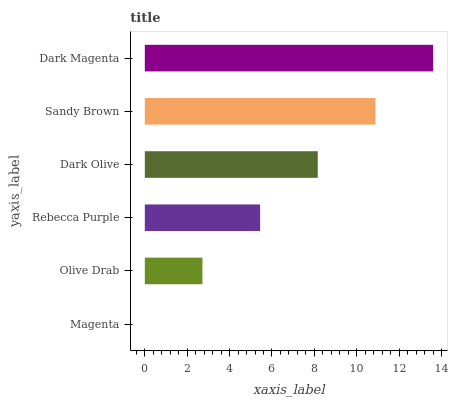Is Magenta the minimum?
Answer yes or no. Yes. Is Dark Magenta the maximum?
Answer yes or no. Yes. Is Olive Drab the minimum?
Answer yes or no. No. Is Olive Drab the maximum?
Answer yes or no. No. Is Olive Drab greater than Magenta?
Answer yes or no. Yes. Is Magenta less than Olive Drab?
Answer yes or no. Yes. Is Magenta greater than Olive Drab?
Answer yes or no. No. Is Olive Drab less than Magenta?
Answer yes or no. No. Is Dark Olive the high median?
Answer yes or no. Yes. Is Rebecca Purple the low median?
Answer yes or no. Yes. Is Dark Magenta the high median?
Answer yes or no. No. Is Dark Olive the low median?
Answer yes or no. No. 